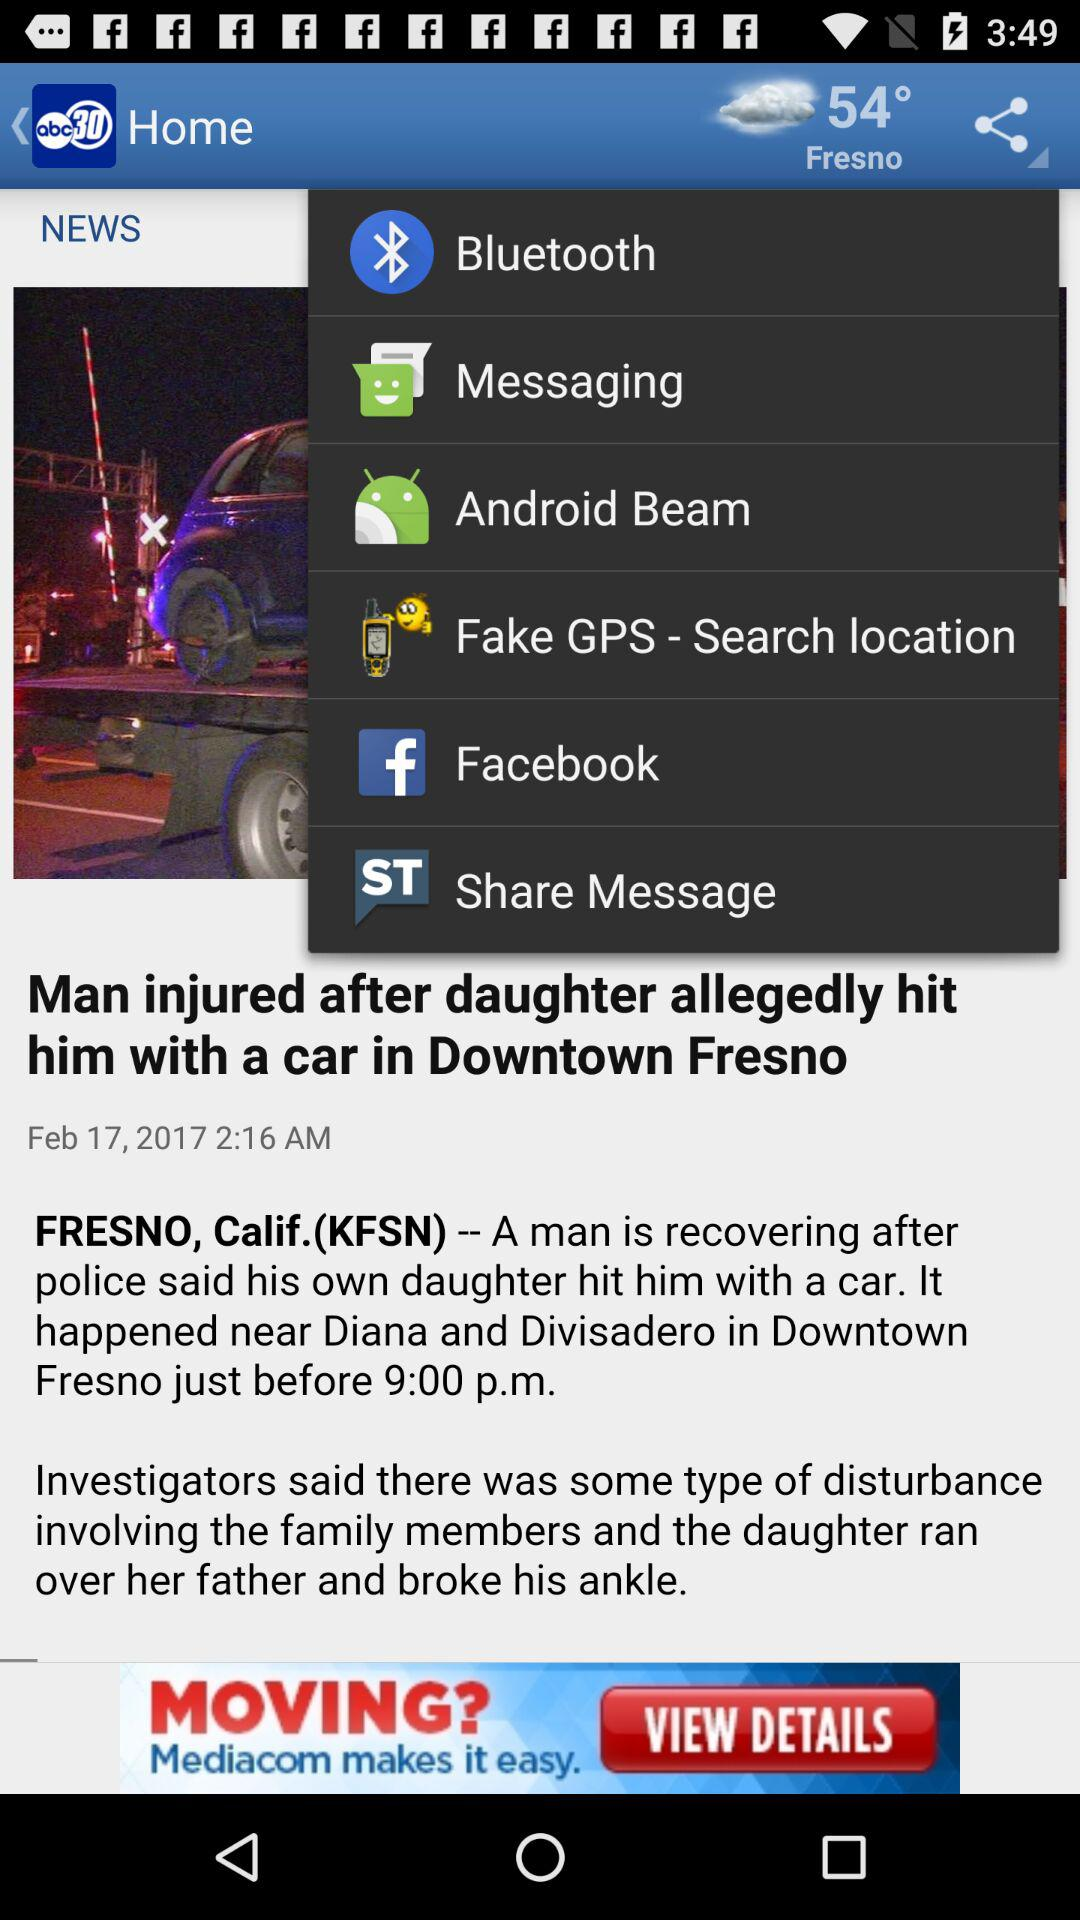On what date was the news "Man injured after daughter allegedly hit him with a car in Downtown Fresno" updated? The news was last updated on February 17, 2017. 